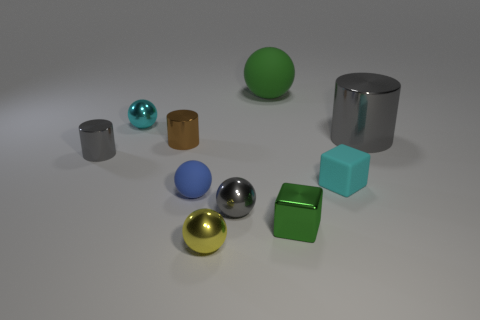Can you describe the atmosphere or mood that this image conveys? The image gives off a calm and serene vibe, with the soft lighting and the orderly arrangement of contrasting shapes and materials. The muted colors and simple background enhance the minimalist yet sophisticated aesthetic of the composition. 